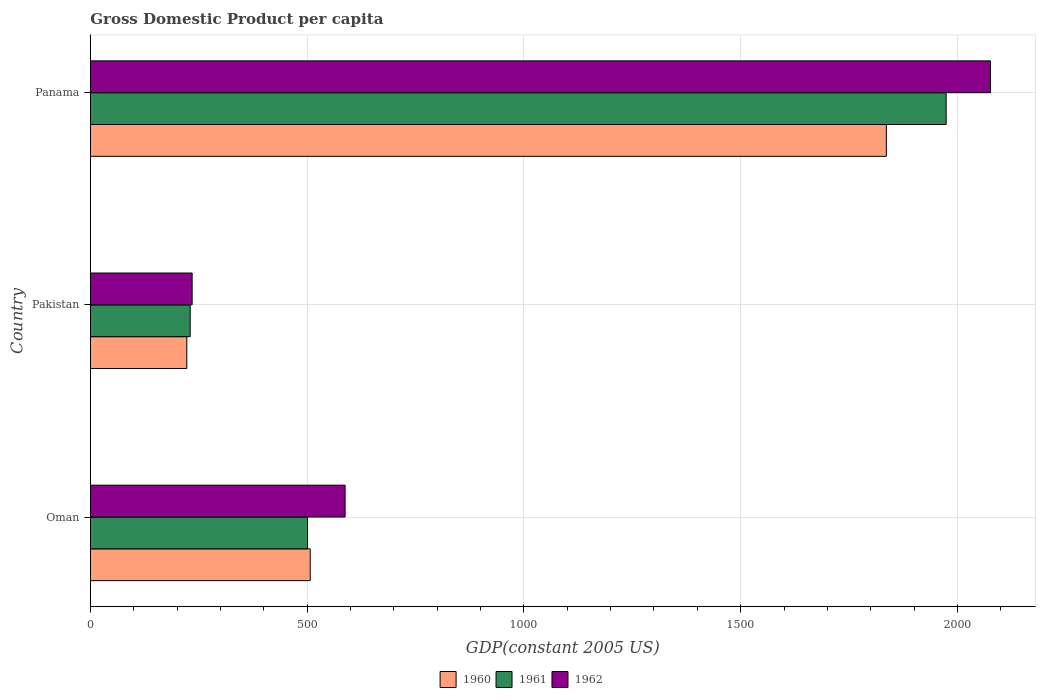How many different coloured bars are there?
Your answer should be compact. 3. How many groups of bars are there?
Your answer should be compact. 3. How many bars are there on the 1st tick from the top?
Your answer should be very brief. 3. How many bars are there on the 2nd tick from the bottom?
Provide a short and direct response. 3. What is the label of the 3rd group of bars from the top?
Make the answer very short. Oman. What is the GDP per capita in 1962 in Pakistan?
Your answer should be very brief. 234.77. Across all countries, what is the maximum GDP per capita in 1960?
Ensure brevity in your answer.  1836.06. Across all countries, what is the minimum GDP per capita in 1961?
Provide a short and direct response. 230.24. In which country was the GDP per capita in 1960 maximum?
Ensure brevity in your answer.  Panama. In which country was the GDP per capita in 1960 minimum?
Your answer should be very brief. Pakistan. What is the total GDP per capita in 1960 in the graph?
Give a very brief answer. 2565.64. What is the difference between the GDP per capita in 1961 in Oman and that in Panama?
Offer a very short reply. -1473.05. What is the difference between the GDP per capita in 1960 in Panama and the GDP per capita in 1961 in Oman?
Your response must be concise. 1335.09. What is the average GDP per capita in 1962 per country?
Provide a short and direct response. 966.22. What is the difference between the GDP per capita in 1962 and GDP per capita in 1960 in Oman?
Provide a short and direct response. 80.48. What is the ratio of the GDP per capita in 1960 in Pakistan to that in Panama?
Provide a succinct answer. 0.12. Is the difference between the GDP per capita in 1962 in Oman and Panama greater than the difference between the GDP per capita in 1960 in Oman and Panama?
Your answer should be very brief. No. What is the difference between the highest and the second highest GDP per capita in 1961?
Ensure brevity in your answer.  1473.05. What is the difference between the highest and the lowest GDP per capita in 1960?
Provide a succinct answer. 1613.62. What does the 2nd bar from the bottom in Panama represents?
Keep it short and to the point. 1961. Is it the case that in every country, the sum of the GDP per capita in 1961 and GDP per capita in 1960 is greater than the GDP per capita in 1962?
Make the answer very short. Yes. What is the difference between two consecutive major ticks on the X-axis?
Make the answer very short. 500. Does the graph contain grids?
Provide a succinct answer. Yes. How many legend labels are there?
Provide a short and direct response. 3. How are the legend labels stacked?
Offer a terse response. Horizontal. What is the title of the graph?
Give a very brief answer. Gross Domestic Product per capita. What is the label or title of the X-axis?
Make the answer very short. GDP(constant 2005 US). What is the GDP(constant 2005 US) in 1960 in Oman?
Provide a short and direct response. 507.14. What is the GDP(constant 2005 US) of 1961 in Oman?
Your answer should be very brief. 500.97. What is the GDP(constant 2005 US) in 1962 in Oman?
Provide a short and direct response. 587.62. What is the GDP(constant 2005 US) in 1960 in Pakistan?
Provide a succinct answer. 222.44. What is the GDP(constant 2005 US) of 1961 in Pakistan?
Give a very brief answer. 230.24. What is the GDP(constant 2005 US) in 1962 in Pakistan?
Make the answer very short. 234.77. What is the GDP(constant 2005 US) of 1960 in Panama?
Make the answer very short. 1836.06. What is the GDP(constant 2005 US) in 1961 in Panama?
Your answer should be very brief. 1974.02. What is the GDP(constant 2005 US) of 1962 in Panama?
Offer a terse response. 2076.28. Across all countries, what is the maximum GDP(constant 2005 US) of 1960?
Provide a succinct answer. 1836.06. Across all countries, what is the maximum GDP(constant 2005 US) of 1961?
Offer a very short reply. 1974.02. Across all countries, what is the maximum GDP(constant 2005 US) in 1962?
Make the answer very short. 2076.28. Across all countries, what is the minimum GDP(constant 2005 US) in 1960?
Offer a very short reply. 222.44. Across all countries, what is the minimum GDP(constant 2005 US) in 1961?
Provide a succinct answer. 230.24. Across all countries, what is the minimum GDP(constant 2005 US) in 1962?
Make the answer very short. 234.77. What is the total GDP(constant 2005 US) in 1960 in the graph?
Your answer should be compact. 2565.64. What is the total GDP(constant 2005 US) of 1961 in the graph?
Ensure brevity in your answer.  2705.23. What is the total GDP(constant 2005 US) of 1962 in the graph?
Provide a short and direct response. 2898.67. What is the difference between the GDP(constant 2005 US) of 1960 in Oman and that in Pakistan?
Give a very brief answer. 284.7. What is the difference between the GDP(constant 2005 US) in 1961 in Oman and that in Pakistan?
Ensure brevity in your answer.  270.73. What is the difference between the GDP(constant 2005 US) of 1962 in Oman and that in Pakistan?
Your answer should be compact. 352.85. What is the difference between the GDP(constant 2005 US) in 1960 in Oman and that in Panama?
Provide a short and direct response. -1328.92. What is the difference between the GDP(constant 2005 US) in 1961 in Oman and that in Panama?
Offer a very short reply. -1473.05. What is the difference between the GDP(constant 2005 US) in 1962 in Oman and that in Panama?
Ensure brevity in your answer.  -1488.67. What is the difference between the GDP(constant 2005 US) of 1960 in Pakistan and that in Panama?
Give a very brief answer. -1613.62. What is the difference between the GDP(constant 2005 US) in 1961 in Pakistan and that in Panama?
Provide a short and direct response. -1743.78. What is the difference between the GDP(constant 2005 US) of 1962 in Pakistan and that in Panama?
Your response must be concise. -1841.51. What is the difference between the GDP(constant 2005 US) in 1960 in Oman and the GDP(constant 2005 US) in 1961 in Pakistan?
Offer a terse response. 276.9. What is the difference between the GDP(constant 2005 US) of 1960 in Oman and the GDP(constant 2005 US) of 1962 in Pakistan?
Your answer should be very brief. 272.37. What is the difference between the GDP(constant 2005 US) in 1961 in Oman and the GDP(constant 2005 US) in 1962 in Pakistan?
Your response must be concise. 266.2. What is the difference between the GDP(constant 2005 US) of 1960 in Oman and the GDP(constant 2005 US) of 1961 in Panama?
Your response must be concise. -1466.88. What is the difference between the GDP(constant 2005 US) of 1960 in Oman and the GDP(constant 2005 US) of 1962 in Panama?
Your answer should be very brief. -1569.14. What is the difference between the GDP(constant 2005 US) in 1961 in Oman and the GDP(constant 2005 US) in 1962 in Panama?
Offer a terse response. -1575.31. What is the difference between the GDP(constant 2005 US) in 1960 in Pakistan and the GDP(constant 2005 US) in 1961 in Panama?
Ensure brevity in your answer.  -1751.58. What is the difference between the GDP(constant 2005 US) in 1960 in Pakistan and the GDP(constant 2005 US) in 1962 in Panama?
Your response must be concise. -1853.84. What is the difference between the GDP(constant 2005 US) in 1961 in Pakistan and the GDP(constant 2005 US) in 1962 in Panama?
Ensure brevity in your answer.  -1846.04. What is the average GDP(constant 2005 US) of 1960 per country?
Offer a very short reply. 855.21. What is the average GDP(constant 2005 US) in 1961 per country?
Provide a succinct answer. 901.74. What is the average GDP(constant 2005 US) in 1962 per country?
Provide a short and direct response. 966.22. What is the difference between the GDP(constant 2005 US) in 1960 and GDP(constant 2005 US) in 1961 in Oman?
Your answer should be very brief. 6.17. What is the difference between the GDP(constant 2005 US) in 1960 and GDP(constant 2005 US) in 1962 in Oman?
Give a very brief answer. -80.48. What is the difference between the GDP(constant 2005 US) of 1961 and GDP(constant 2005 US) of 1962 in Oman?
Offer a very short reply. -86.64. What is the difference between the GDP(constant 2005 US) of 1960 and GDP(constant 2005 US) of 1961 in Pakistan?
Offer a very short reply. -7.8. What is the difference between the GDP(constant 2005 US) in 1960 and GDP(constant 2005 US) in 1962 in Pakistan?
Ensure brevity in your answer.  -12.33. What is the difference between the GDP(constant 2005 US) in 1961 and GDP(constant 2005 US) in 1962 in Pakistan?
Provide a short and direct response. -4.53. What is the difference between the GDP(constant 2005 US) in 1960 and GDP(constant 2005 US) in 1961 in Panama?
Keep it short and to the point. -137.96. What is the difference between the GDP(constant 2005 US) of 1960 and GDP(constant 2005 US) of 1962 in Panama?
Make the answer very short. -240.22. What is the difference between the GDP(constant 2005 US) of 1961 and GDP(constant 2005 US) of 1962 in Panama?
Your answer should be compact. -102.27. What is the ratio of the GDP(constant 2005 US) in 1960 in Oman to that in Pakistan?
Your response must be concise. 2.28. What is the ratio of the GDP(constant 2005 US) of 1961 in Oman to that in Pakistan?
Offer a terse response. 2.18. What is the ratio of the GDP(constant 2005 US) of 1962 in Oman to that in Pakistan?
Provide a short and direct response. 2.5. What is the ratio of the GDP(constant 2005 US) in 1960 in Oman to that in Panama?
Offer a terse response. 0.28. What is the ratio of the GDP(constant 2005 US) of 1961 in Oman to that in Panama?
Your answer should be compact. 0.25. What is the ratio of the GDP(constant 2005 US) of 1962 in Oman to that in Panama?
Keep it short and to the point. 0.28. What is the ratio of the GDP(constant 2005 US) in 1960 in Pakistan to that in Panama?
Provide a short and direct response. 0.12. What is the ratio of the GDP(constant 2005 US) of 1961 in Pakistan to that in Panama?
Provide a succinct answer. 0.12. What is the ratio of the GDP(constant 2005 US) in 1962 in Pakistan to that in Panama?
Provide a short and direct response. 0.11. What is the difference between the highest and the second highest GDP(constant 2005 US) of 1960?
Your response must be concise. 1328.92. What is the difference between the highest and the second highest GDP(constant 2005 US) of 1961?
Give a very brief answer. 1473.05. What is the difference between the highest and the second highest GDP(constant 2005 US) in 1962?
Make the answer very short. 1488.67. What is the difference between the highest and the lowest GDP(constant 2005 US) in 1960?
Your response must be concise. 1613.62. What is the difference between the highest and the lowest GDP(constant 2005 US) in 1961?
Offer a very short reply. 1743.78. What is the difference between the highest and the lowest GDP(constant 2005 US) in 1962?
Provide a short and direct response. 1841.51. 